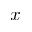<formula> <loc_0><loc_0><loc_500><loc_500>x</formula> 